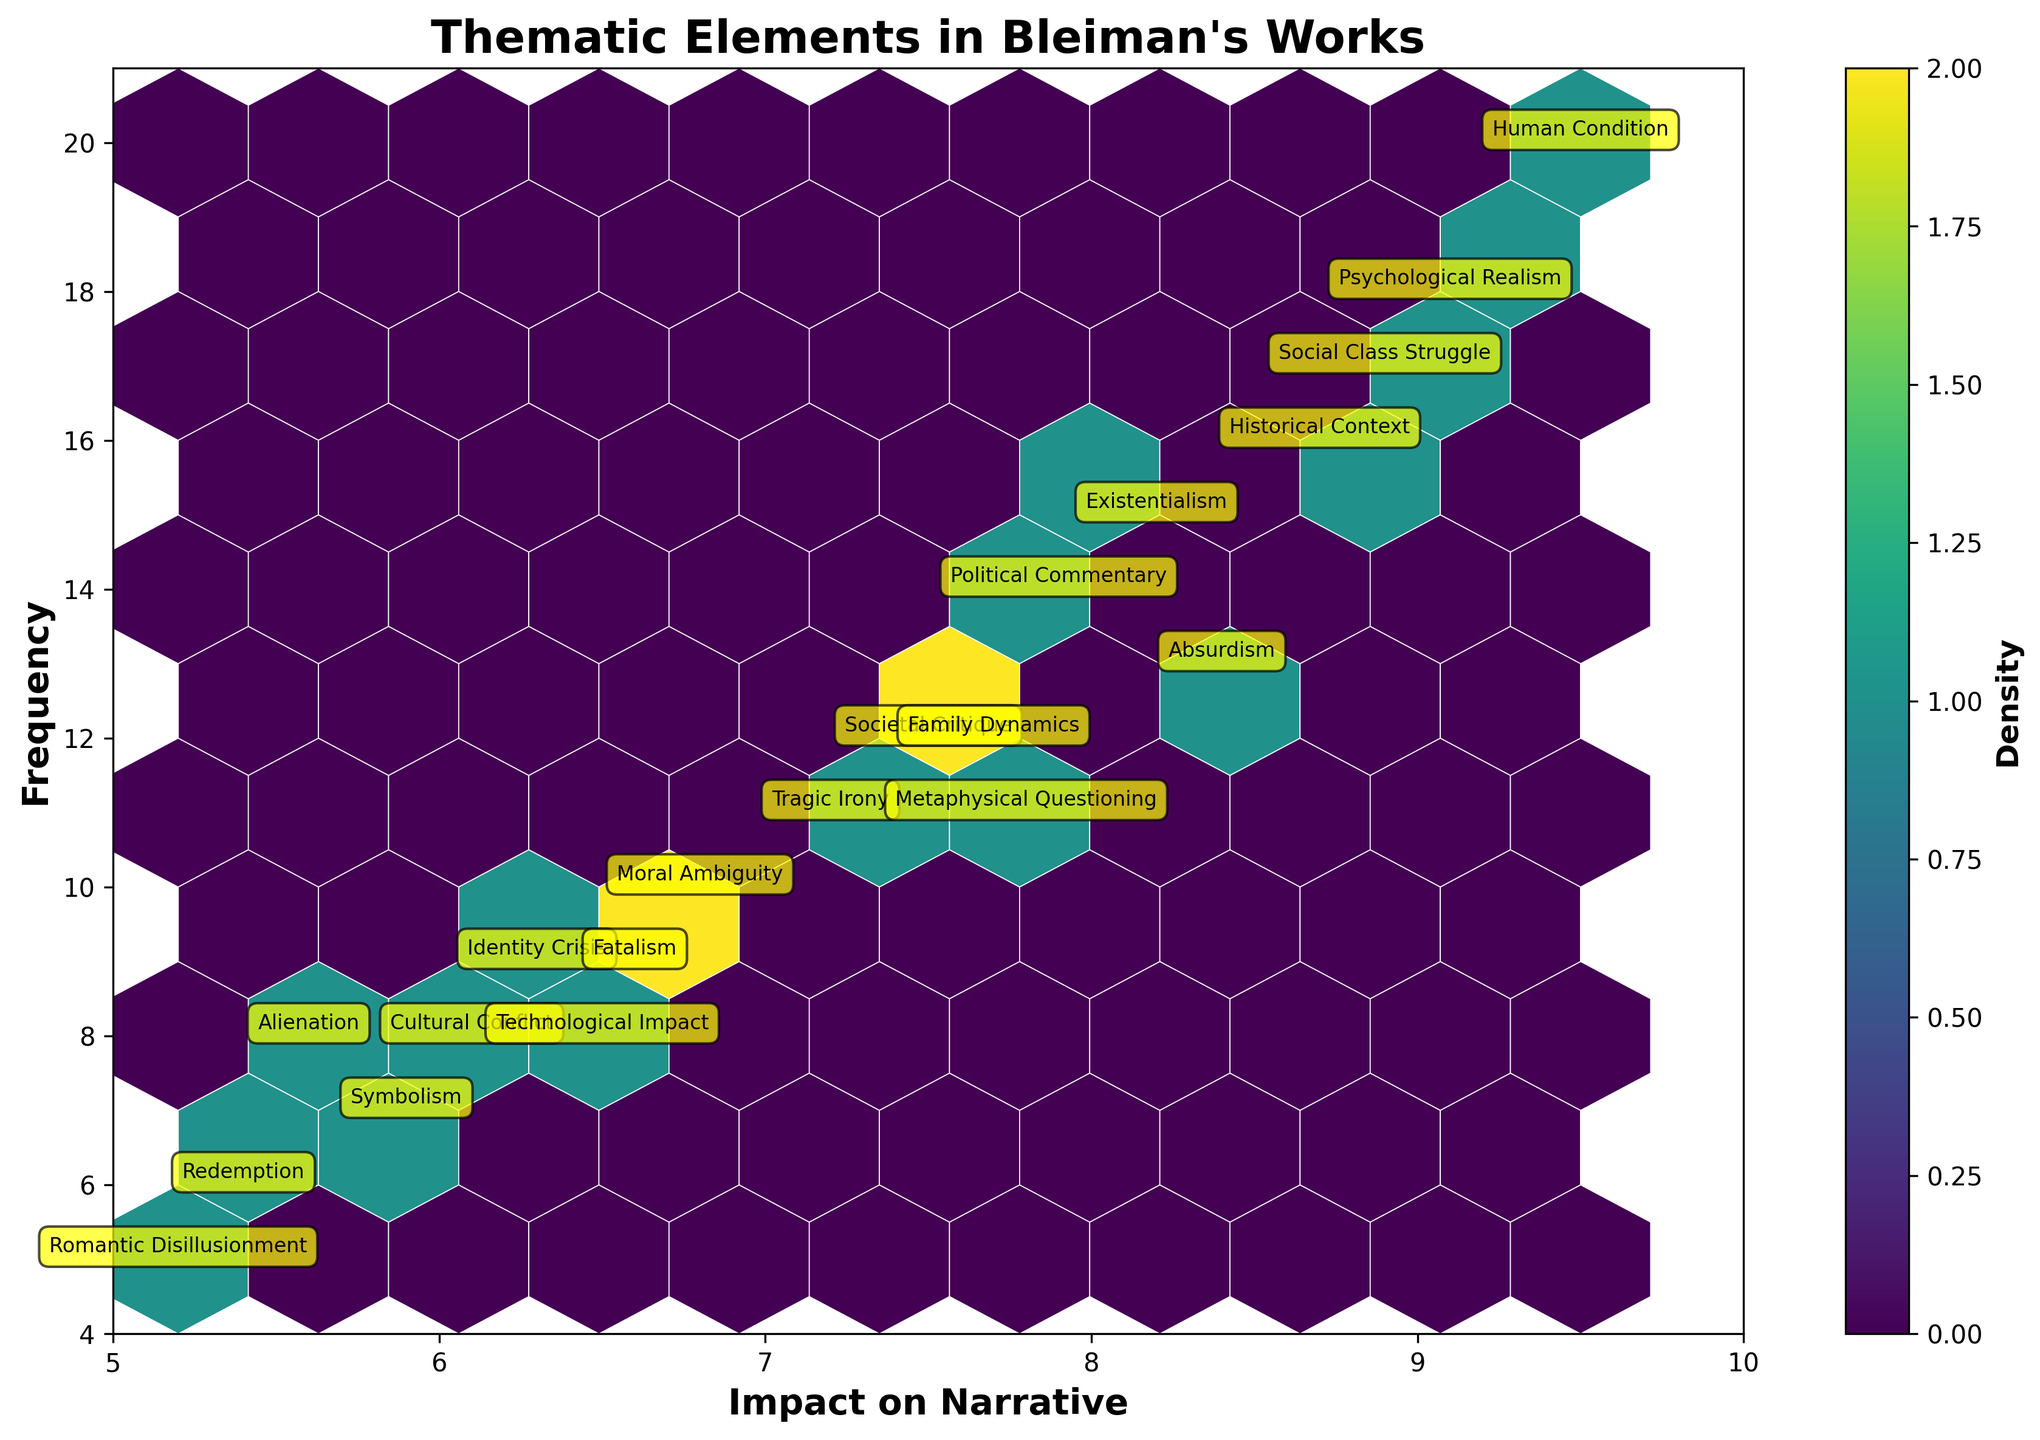What is the title of the plot? The title is written at the top of the figure. Reading this title helps identify what the plot is about.
Answer: Thematic Elements in Bleiman's Works Which thematic element has the highest frequency? Locate the data point that is highest along the vertical axis labeled 'Frequency', and check the annotation for that point.
Answer: Human Condition What impact on narrative value corresponds to the theme 'Absurdism'? Find the annotation for 'Absurdism' and read its position along the horizontal axis labeled 'Impact on Narrative'.
Answer: 8.4 How many thematic elements have a frequency of 12? Identify data points with a vertical value of 12. Count the number of these points from the annotations.
Answer: 2 Which theme has a higher frequency, 'Political Commentary' or 'Family Dynamics'? Find both themes on the plot. Compare their vertical positions based on their frequencies.
Answer: Political Commentary What is the average frequency of the themes with an impact on narrative of more than 8? Identify themes with narrative impacts greater than 8: 'Existentialism', 'Psychological Realism', 'Historical Context', 'Human Condition', 'Absurdism', 'Social Class Struggle'. Sum their frequencies and divide by the number of themes. \(((15 + 18 + 16 + 20 + 13 + 17) / 6)\)
Answer: 16.5 Which thematic element has a frequency closest to 10? Look for the data point nearest to a vertical value of 10 and check the annotation.
Answer: Moral Ambiguity What are the ranges of the color bar's density values? The density color bar shows the range, usually indicated from lowest to highest values.
Answer: Lowest to highest density For the theme 'Tragic Irony', what is its impact on narrative and frequency? Locate 'Tragic Irony' on the plot. Read its horizontal (impact on narrative) and vertical (frequency) positions.
Answer: 7.2, 11 How many themes are grouped in the hexbin plot above a frequency of 14? Count the number of data points with a vertical value greater than 14.
Answer: 6 